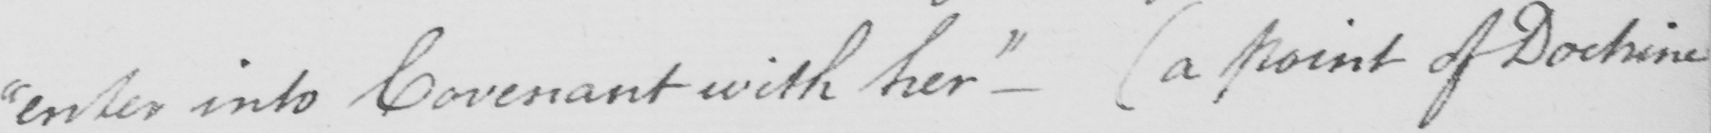What does this handwritten line say? " enter into Covenant with her "   _   ( a point of Doctrine 